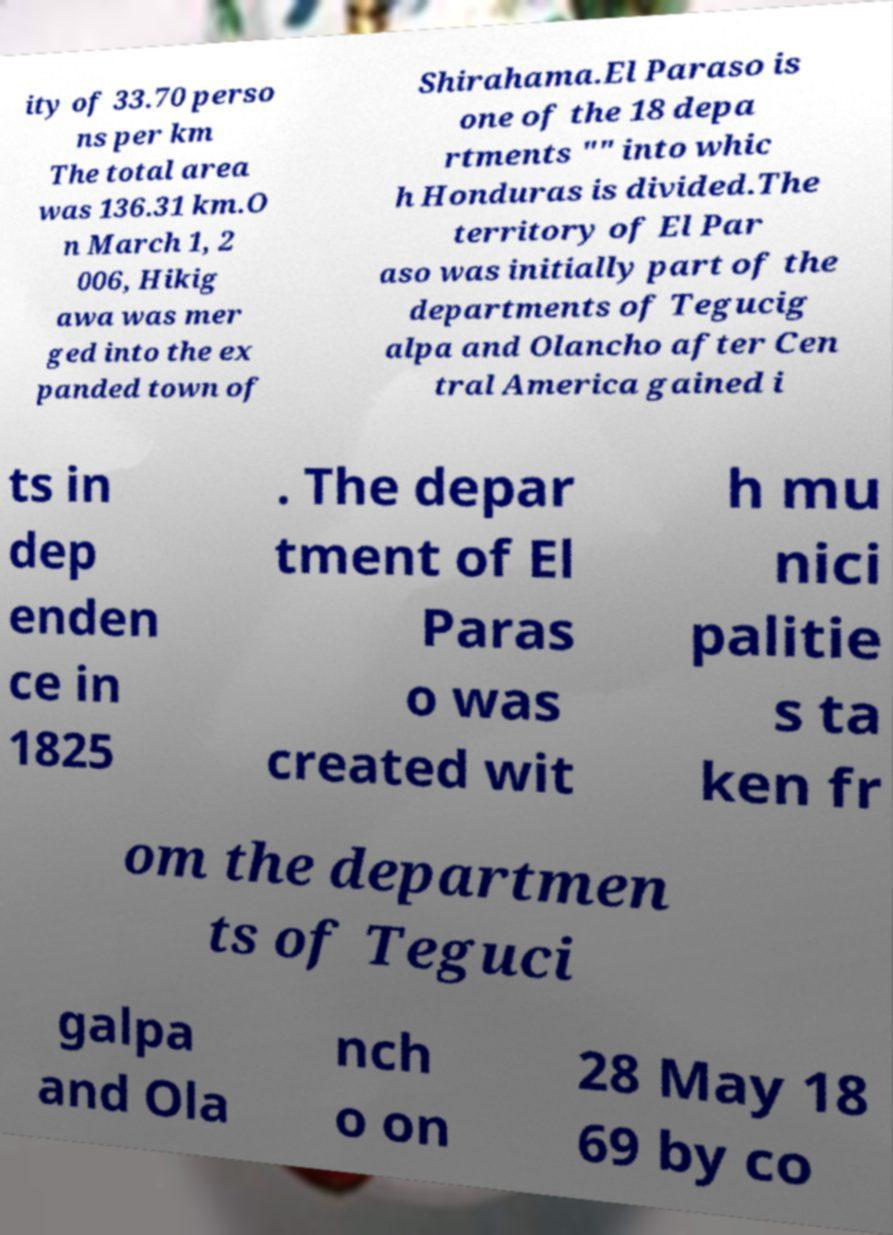Could you extract and type out the text from this image? ity of 33.70 perso ns per km The total area was 136.31 km.O n March 1, 2 006, Hikig awa was mer ged into the ex panded town of Shirahama.El Paraso is one of the 18 depa rtments "" into whic h Honduras is divided.The territory of El Par aso was initially part of the departments of Tegucig alpa and Olancho after Cen tral America gained i ts in dep enden ce in 1825 . The depar tment of El Paras o was created wit h mu nici palitie s ta ken fr om the departmen ts of Teguci galpa and Ola nch o on 28 May 18 69 by co 